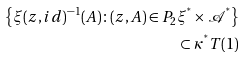Convert formula to latex. <formula><loc_0><loc_0><loc_500><loc_500>\left \{ \xi ( z , i d ) ^ { - 1 } ( A ) \colon ( z , A ) \in P _ { 2 } \xi ^ { ^ { * } } \times \mathcal { A } ^ { ^ { * } } \right \} \\ \subset \kappa ^ { ^ { * } } T ( 1 )</formula> 